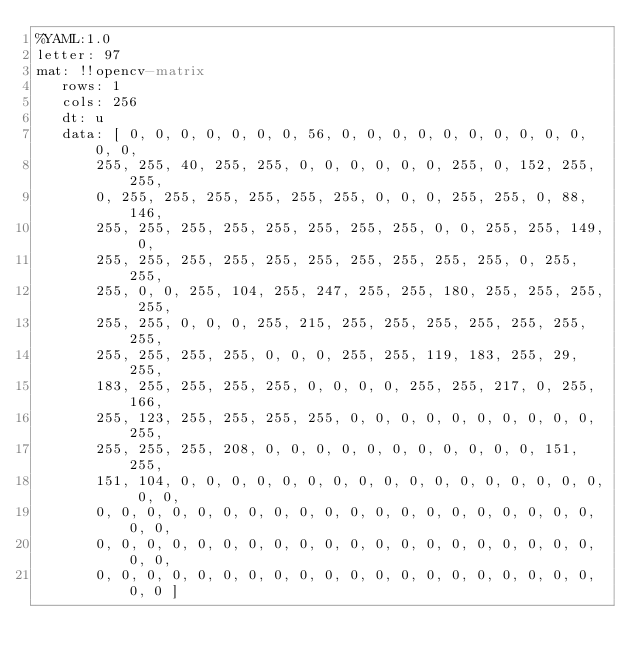Convert code to text. <code><loc_0><loc_0><loc_500><loc_500><_YAML_>%YAML:1.0
letter: 97
mat: !!opencv-matrix
   rows: 1
   cols: 256
   dt: u
   data: [ 0, 0, 0, 0, 0, 0, 0, 56, 0, 0, 0, 0, 0, 0, 0, 0, 0, 0, 0, 0,
       255, 255, 40, 255, 255, 0, 0, 0, 0, 0, 0, 255, 0, 152, 255, 255,
       0, 255, 255, 255, 255, 255, 255, 0, 0, 0, 255, 255, 0, 88, 146,
       255, 255, 255, 255, 255, 255, 255, 255, 0, 0, 255, 255, 149, 0,
       255, 255, 255, 255, 255, 255, 255, 255, 255, 255, 0, 255, 255,
       255, 0, 0, 255, 104, 255, 247, 255, 255, 180, 255, 255, 255, 255,
       255, 255, 0, 0, 0, 255, 215, 255, 255, 255, 255, 255, 255, 255,
       255, 255, 255, 255, 0, 0, 0, 255, 255, 119, 183, 255, 29, 255,
       183, 255, 255, 255, 255, 0, 0, 0, 0, 255, 255, 217, 0, 255, 166,
       255, 123, 255, 255, 255, 255, 0, 0, 0, 0, 0, 0, 0, 0, 0, 0, 255,
       255, 255, 255, 208, 0, 0, 0, 0, 0, 0, 0, 0, 0, 0, 0, 151, 255,
       151, 104, 0, 0, 0, 0, 0, 0, 0, 0, 0, 0, 0, 0, 0, 0, 0, 0, 0, 0, 0,
       0, 0, 0, 0, 0, 0, 0, 0, 0, 0, 0, 0, 0, 0, 0, 0, 0, 0, 0, 0, 0, 0,
       0, 0, 0, 0, 0, 0, 0, 0, 0, 0, 0, 0, 0, 0, 0, 0, 0, 0, 0, 0, 0, 0,
       0, 0, 0, 0, 0, 0, 0, 0, 0, 0, 0, 0, 0, 0, 0, 0, 0, 0, 0, 0, 0, 0 ]
</code> 